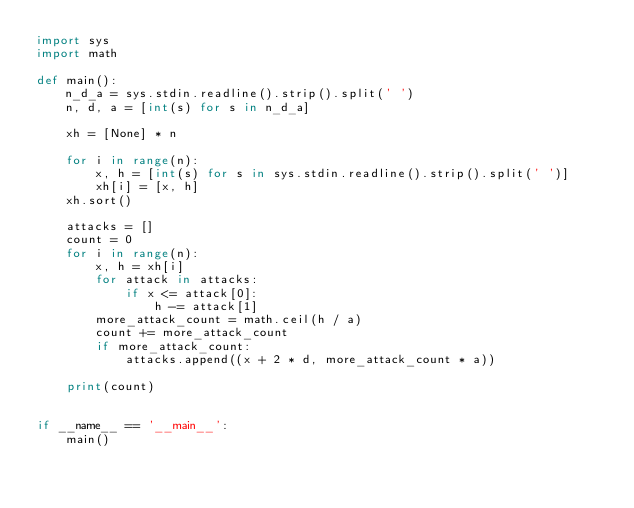<code> <loc_0><loc_0><loc_500><loc_500><_Python_>import sys
import math

def main():
    n_d_a = sys.stdin.readline().strip().split(' ')
    n, d, a = [int(s) for s in n_d_a]

    xh = [None] * n

    for i in range(n):
        x, h = [int(s) for s in sys.stdin.readline().strip().split(' ')]
        xh[i] = [x, h]
    xh.sort()

    attacks = []
    count = 0
    for i in range(n):
        x, h = xh[i]
        for attack in attacks:
            if x <= attack[0]:
                h -= attack[1]
        more_attack_count = math.ceil(h / a)
        count += more_attack_count
        if more_attack_count:
            attacks.append((x + 2 * d, more_attack_count * a))

    print(count)
    

if __name__ == '__main__':
    main()
</code> 